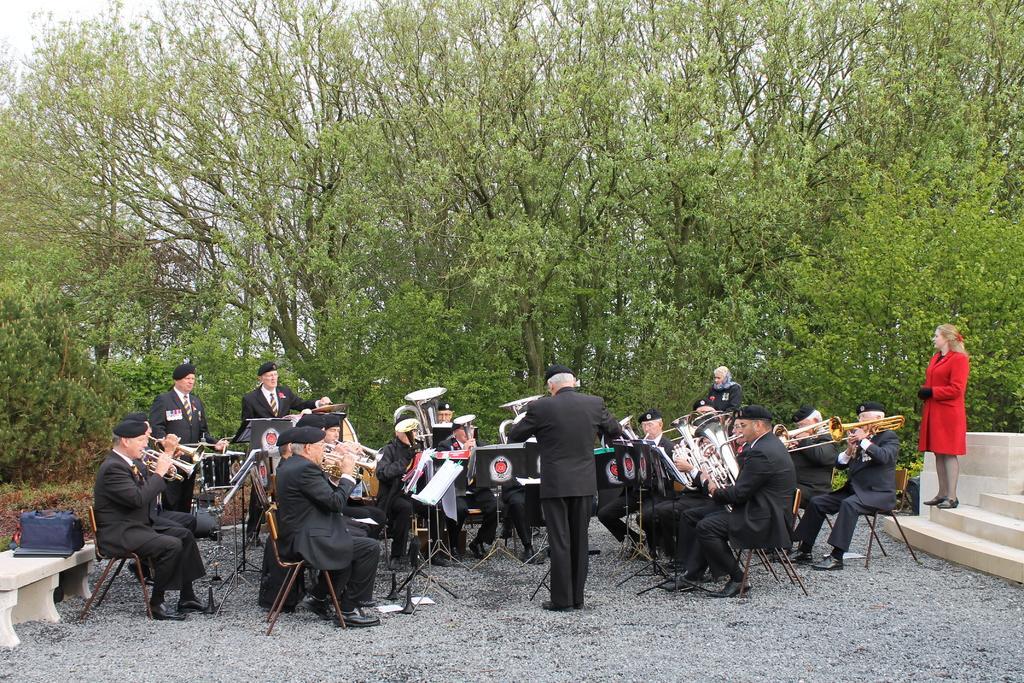In one or two sentences, can you explain what this image depicts? In this picture there are group of people sitting on the chairs and playing musical instruments. There are group of people standing. On the right side of the image there is a woman with red dress is standing on the staircase. In the middle of the image there are objects. On the left side of the image there is a bag on the bench. At the back there are trees. At the top there is sky. 